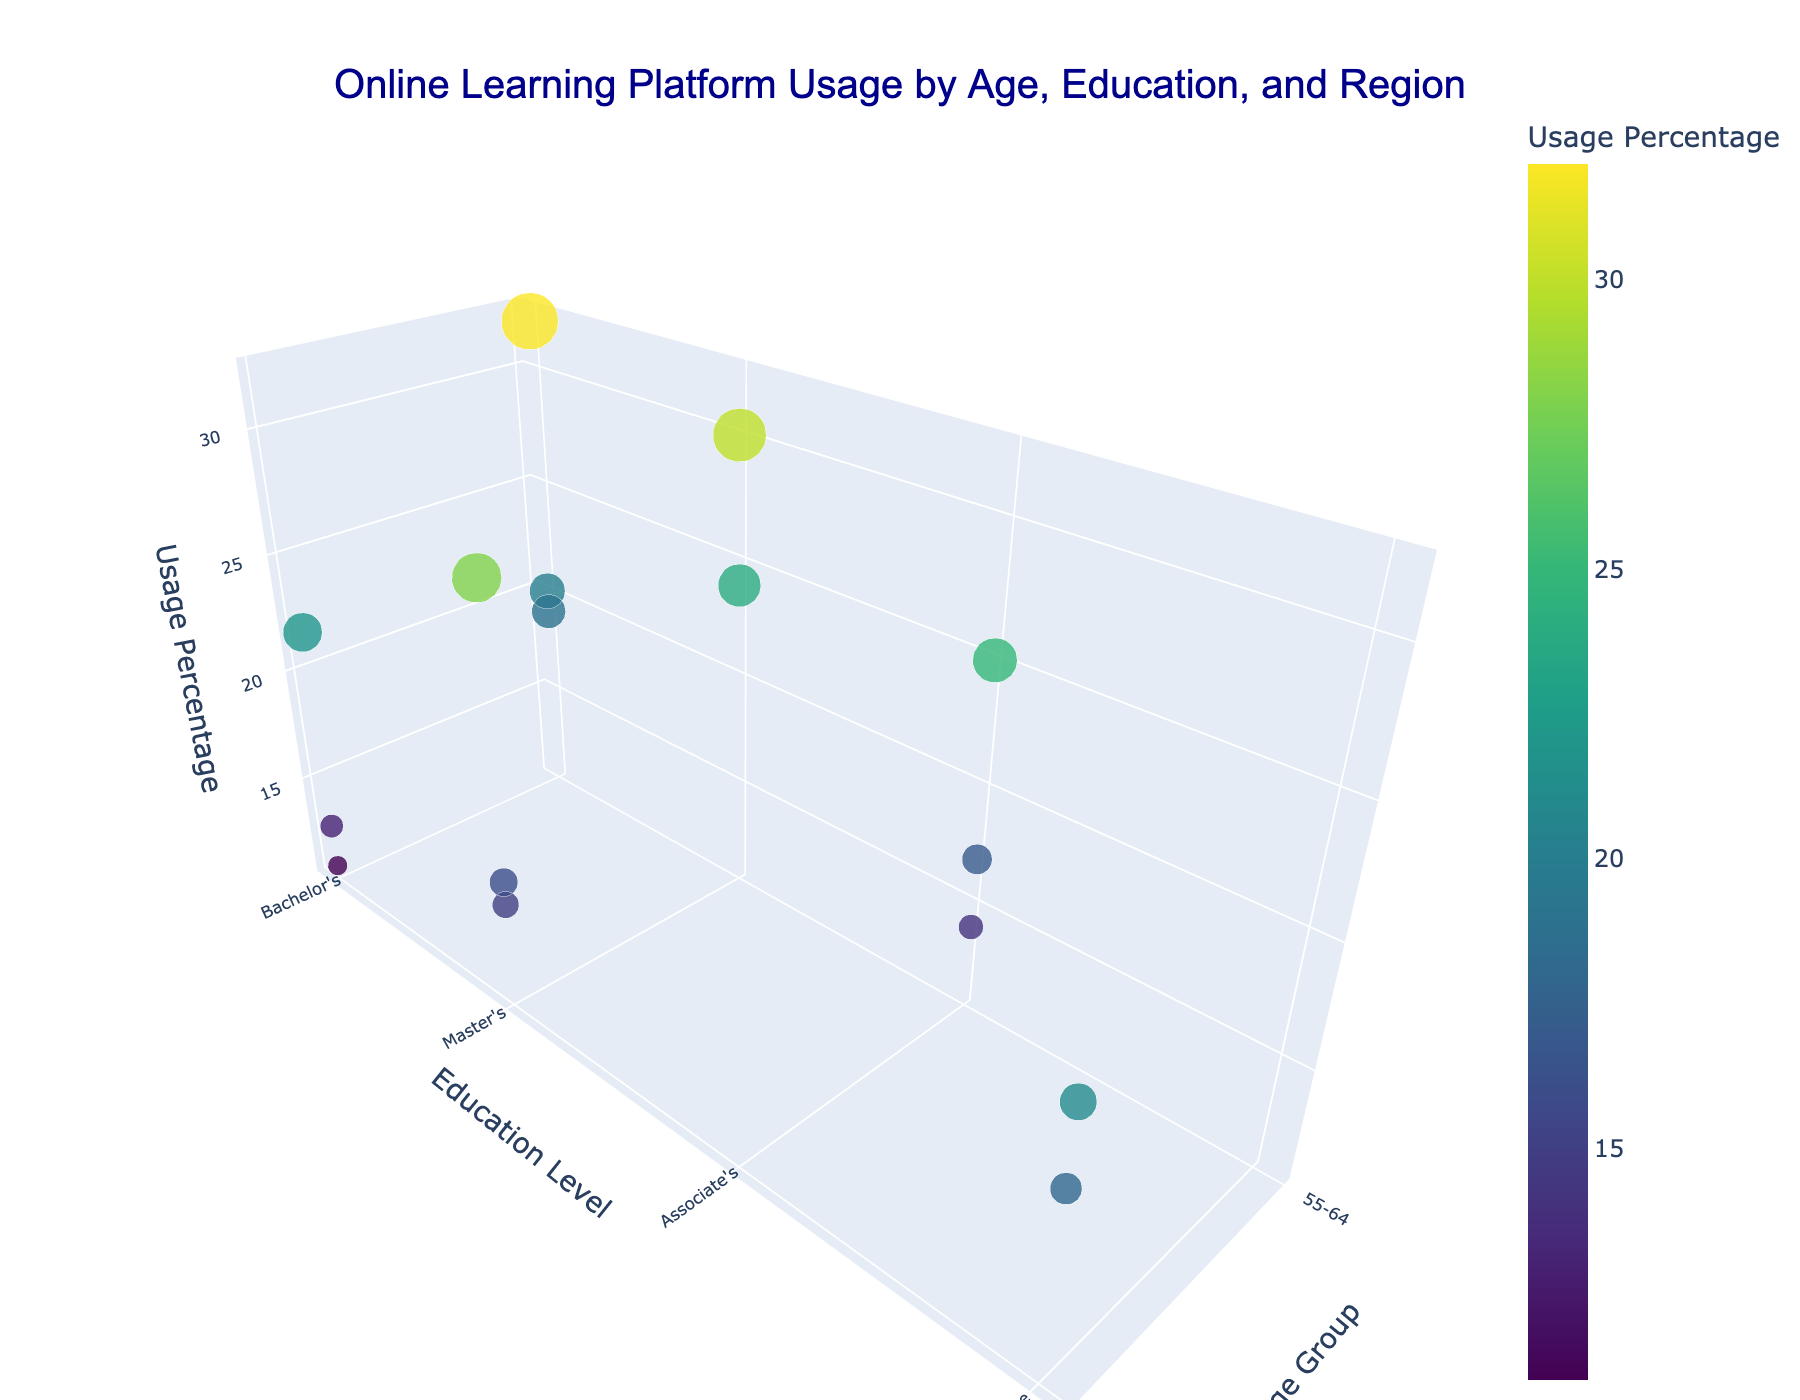What is the title of the plot? The title is an obvious element typically found at the top center of the plot. It provides a brief description of what the plot is about. In this case, you can see the title is 'Online Learning Platform Usage by Age, Education, and Region'.
Answer: Online Learning Platform Usage by Age, Education, and Region What are the three variables on the axes in this 3D plot? Each axis in a 3D plot represents a variable. The x-axis is labeled 'Age Group', the y-axis is labeled 'Education Level', and the z-axis is labeled 'Usage Percentage'. These labels help understand what each axis represents.
Answer: Age Group, Education Level, Usage Percentage Which age group has the highest usage percentage, and in which region? By observing the z-axis (Usage Percentage) and the corresponding points, we notice that the highest usage percentage is in the '55-64' age group for the 'United Kingdom' region. The tooltip or hover information can assist in verifying this.
Answer: 55-64, United Kingdom What is the overall trend when comparing the 'Bachelor's' education level across different regions in the '55-64' age group? To determine the trend, analyze the markers corresponding to the '55-64' age group and 'Bachelor's' education level along the z-axis for different regions. Generally, the values range from 19% in Japan to 32% in the UK, showing considerable variability.
Answer: Variable with a high in the UK Which region has the lowest usage percentage, and what is the age group and education level for this data point? Look for the point with the smallest z-value, which represents the lowest usage percentage. The tooltip can help reveal that it is 'Brazil' for the '65+' age group with a 'Bachelor's' level.
Answer: Brazil, 65+, Bachelor's Compare the usage percentage between the 'Master's' level in 'Australia' for '55-64' age group and 'France' for '65+' age group. Which is higher? Identify the respective points and compare their z-values (Usage Percentage). Australia's 'Master's' level for '55-64' is 30%, while France's 'Master's' level for '65+' is 15%. Australia has the higher usage percentage.
Answer: Australia (30%) What is the average usage percentage for the '65+' age group in all regions combined? First, sum the usage percentages for all '65+' age group data points (28+22+18+15+13+21+16+11). Then, divide by the number of data points (8). Calculation: (28+22+18+15+13+21+16+11) / 8 = 144 / 8 = 18.
Answer: 18 How does the usage percentage for 'Associate's' level in 'United States' compare to 'India', for the '55-64' age group? Identify the corresponding points and compare their z-values (Usage Percentage). The United States has 25%, while India has 14%. The United States has a higher usage percentage.
Answer: United States (25%) Which region shows a higher usage percentage for 'Doctorate' level, 'Canada' or 'Sweden'? Check the z-values for 'Doctorate' education level in both regions. Canada has 18% and Sweden has 21%. Sweden shows a higher usage percentage.
Answer: Sweden (21%) Is there a noticeable difference in usage percentage between the 'Bachelor's' and 'Master's' levels in 'United Kingdom' for the '65+' age group? Identify the respective points and compare their z-values. The '65+' Bachelor's level in the UK isn't directly given, but the '65+' Master's level is 28%. Since only one '65+' data point in the UK, no direct comparison can be made.
Answer: Not applicable 